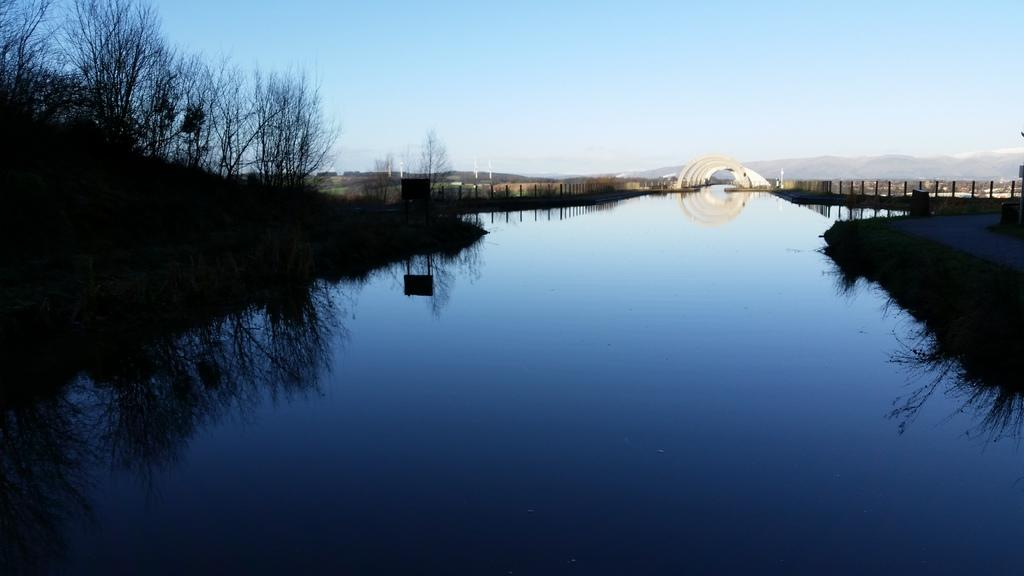What is the main feature in the center of the image? There is a canal in the center of the image. What type of vegetation can be seen in the image? There are trees in the image. What type of barrier is present in the image? There is a fence in the image. What can be seen in the distance in the image? There are hills visible in the background of the image. What is visible above the landscape in the image? The sky is visible in the background of the image. What type of chair is the governor sitting on in the image? There is no governor or chair present in the image. 